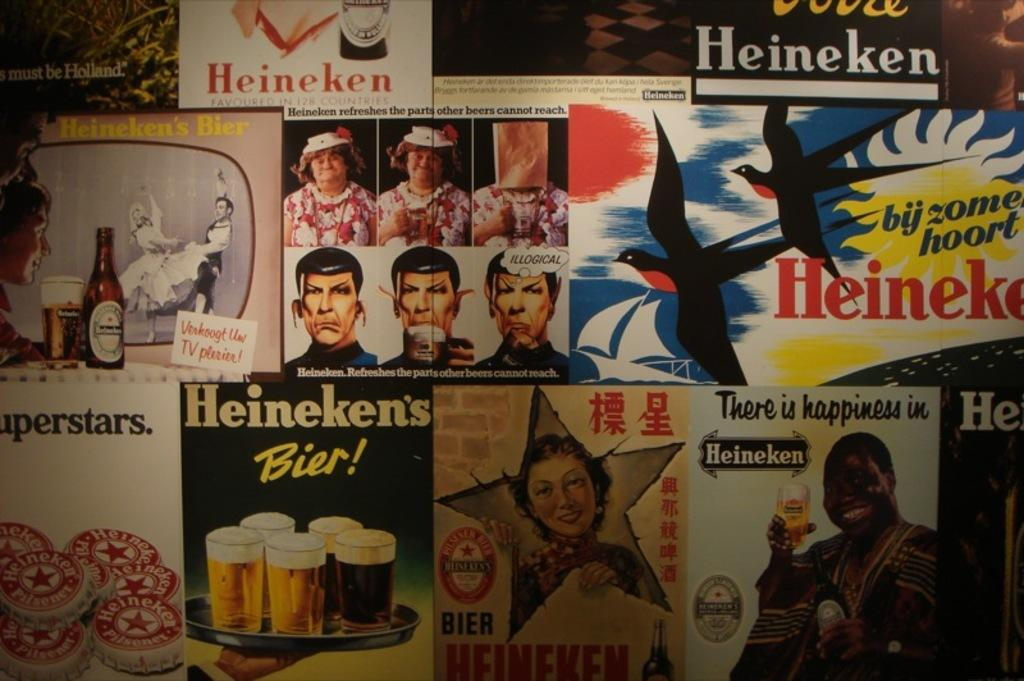What is the main subject of the posters in the image? The posters contain images of ladies, men, glasses, bottles, and a bird. Can you describe the types of objects depicted on the posters? The posters contain images of glasses and bottles. Are there any living creatures depicted on the posters? Yes, there is an image of a bird on one of the posters. What else can be found on the posters besides images? There is writing on the posters. How many seats are visible in the image? There are no seats visible in the image; the image only contains posters. What type of crime is being committed in the image? There is no crime depicted in the image; it only contains posters with various images and writing. 